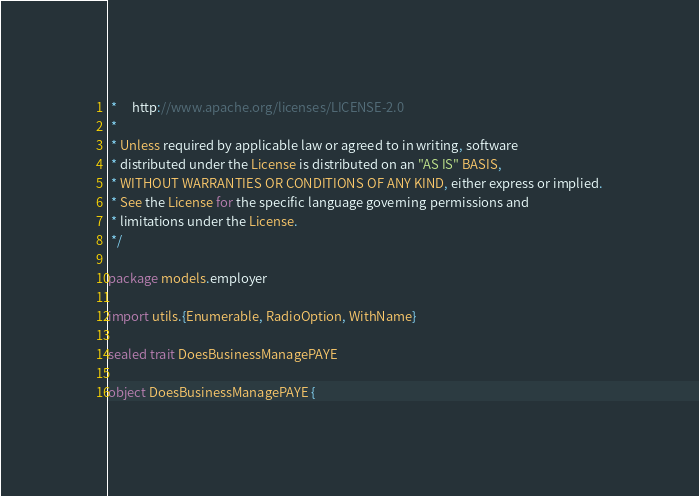<code> <loc_0><loc_0><loc_500><loc_500><_Scala_> *     http://www.apache.org/licenses/LICENSE-2.0
 *
 * Unless required by applicable law or agreed to in writing, software
 * distributed under the License is distributed on an "AS IS" BASIS,
 * WITHOUT WARRANTIES OR CONDITIONS OF ANY KIND, either express or implied.
 * See the License for the specific language governing permissions and
 * limitations under the License.
 */

package models.employer

import utils.{Enumerable, RadioOption, WithName}

sealed trait DoesBusinessManagePAYE

object DoesBusinessManagePAYE {
</code> 